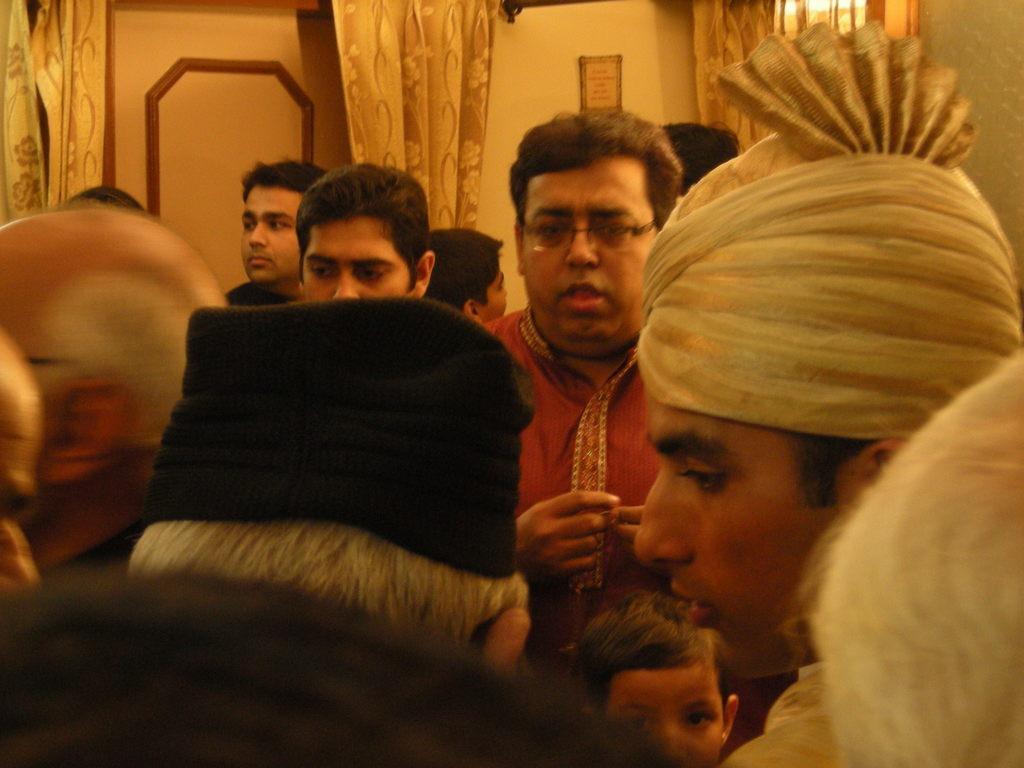Can you describe this image briefly? In this picture we can see a group of people and in the background we can see curtains and a frame on the wall. 